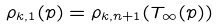<formula> <loc_0><loc_0><loc_500><loc_500>\rho _ { k , 1 } ( p ) = \rho _ { k , n + 1 } ( T _ { \infty } ( p ) )</formula> 